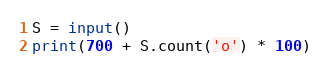<code> <loc_0><loc_0><loc_500><loc_500><_Python_>S = input()
print(700 + S.count('o') * 100)</code> 